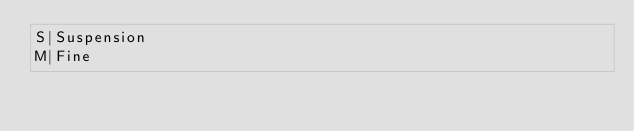<code> <loc_0><loc_0><loc_500><loc_500><_SQL_>S|Suspension
M|Fine</code> 